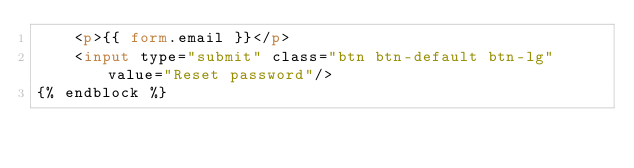<code> <loc_0><loc_0><loc_500><loc_500><_HTML_>    <p>{{ form.email }}</p>
    <input type="submit" class="btn btn-default btn-lg" value="Reset password"/>
{% endblock %}</code> 